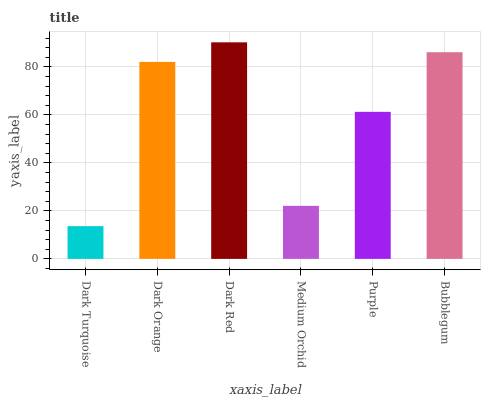Is Dark Turquoise the minimum?
Answer yes or no. Yes. Is Dark Red the maximum?
Answer yes or no. Yes. Is Dark Orange the minimum?
Answer yes or no. No. Is Dark Orange the maximum?
Answer yes or no. No. Is Dark Orange greater than Dark Turquoise?
Answer yes or no. Yes. Is Dark Turquoise less than Dark Orange?
Answer yes or no. Yes. Is Dark Turquoise greater than Dark Orange?
Answer yes or no. No. Is Dark Orange less than Dark Turquoise?
Answer yes or no. No. Is Dark Orange the high median?
Answer yes or no. Yes. Is Purple the low median?
Answer yes or no. Yes. Is Medium Orchid the high median?
Answer yes or no. No. Is Dark Turquoise the low median?
Answer yes or no. No. 